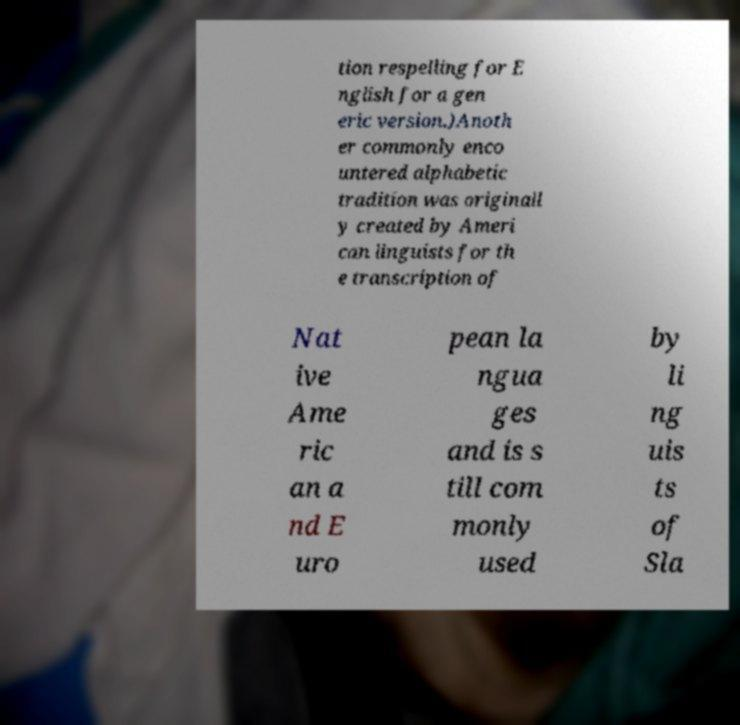What messages or text are displayed in this image? I need them in a readable, typed format. tion respelling for E nglish for a gen eric version.)Anoth er commonly enco untered alphabetic tradition was originall y created by Ameri can linguists for th e transcription of Nat ive Ame ric an a nd E uro pean la ngua ges and is s till com monly used by li ng uis ts of Sla 